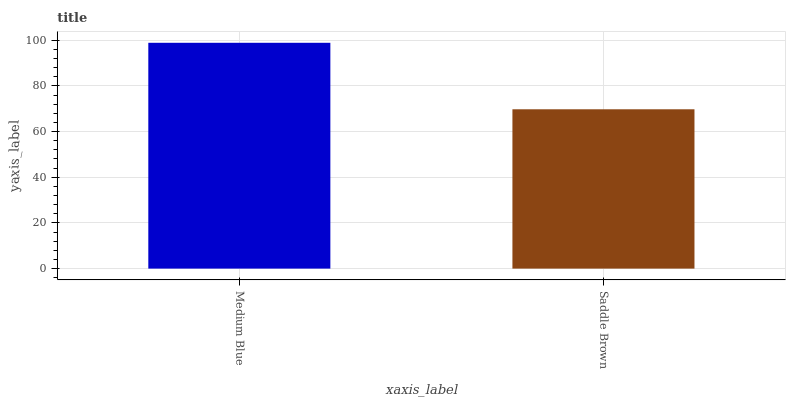Is Saddle Brown the minimum?
Answer yes or no. Yes. Is Medium Blue the maximum?
Answer yes or no. Yes. Is Saddle Brown the maximum?
Answer yes or no. No. Is Medium Blue greater than Saddle Brown?
Answer yes or no. Yes. Is Saddle Brown less than Medium Blue?
Answer yes or no. Yes. Is Saddle Brown greater than Medium Blue?
Answer yes or no. No. Is Medium Blue less than Saddle Brown?
Answer yes or no. No. Is Medium Blue the high median?
Answer yes or no. Yes. Is Saddle Brown the low median?
Answer yes or no. Yes. Is Saddle Brown the high median?
Answer yes or no. No. Is Medium Blue the low median?
Answer yes or no. No. 